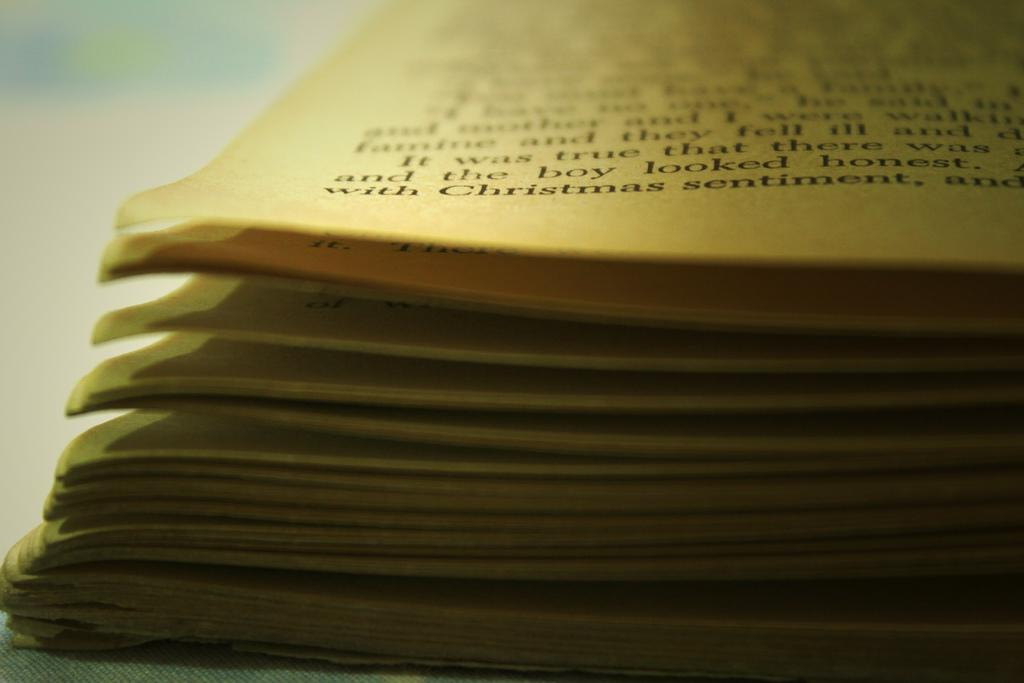<image>
Give a short and clear explanation of the subsequent image. A book with faded pages mentions a boy and Christmas sentiment. 